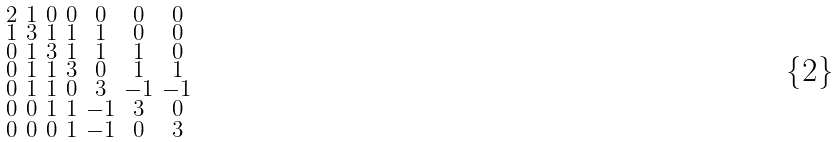Convert formula to latex. <formula><loc_0><loc_0><loc_500><loc_500>\begin{smallmatrix} 2 & 1 & 0 & 0 & 0 & 0 & 0 \\ 1 & 3 & 1 & 1 & 1 & 0 & 0 \\ 0 & 1 & 3 & 1 & 1 & 1 & 0 \\ 0 & 1 & 1 & 3 & 0 & 1 & 1 \\ 0 & 1 & 1 & 0 & 3 & - 1 & - 1 \\ 0 & 0 & 1 & 1 & - 1 & 3 & 0 \\ 0 & 0 & 0 & 1 & - 1 & 0 & 3 \end{smallmatrix}</formula> 